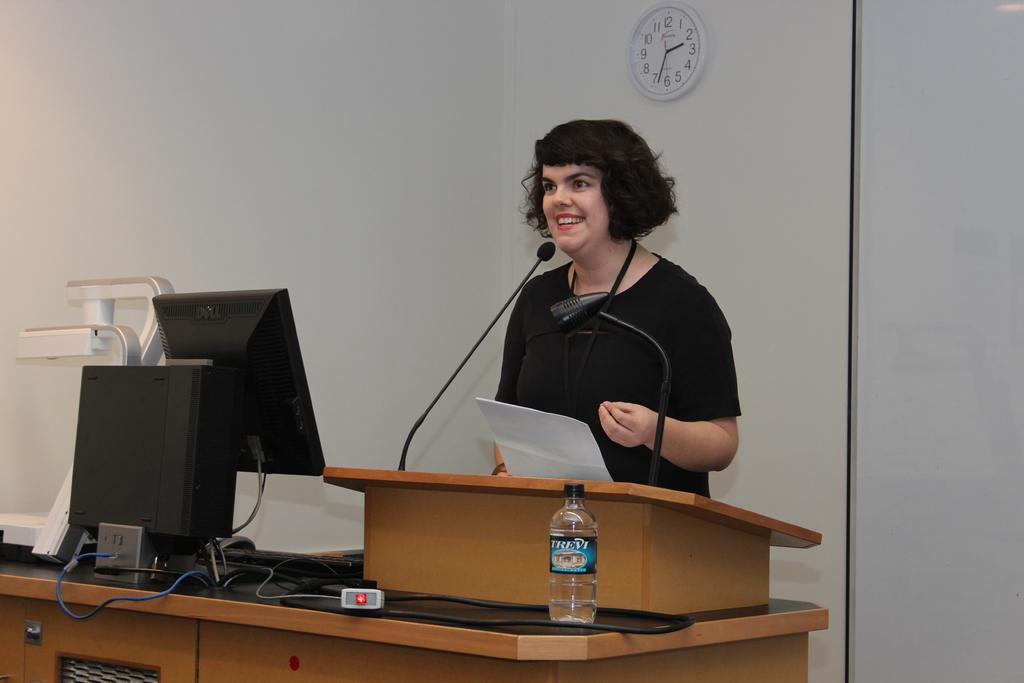Who is the main subject in the image? There is a woman in the image. What is the woman doing in the image? The woman is standing and talking over a microphone. What objects can be seen on the table in the image? There is a monitor, a keyboard, a mouse, a bottle, and a clock mounted on the wall behind the table. What type of drum is being played by the woman in the image? There is no drum present in the image; the woman is talking over a microphone. What caused the woman to lose her voice in the image? There is no indication in the image that the woman has lost her voice or that there is a cause for it. 